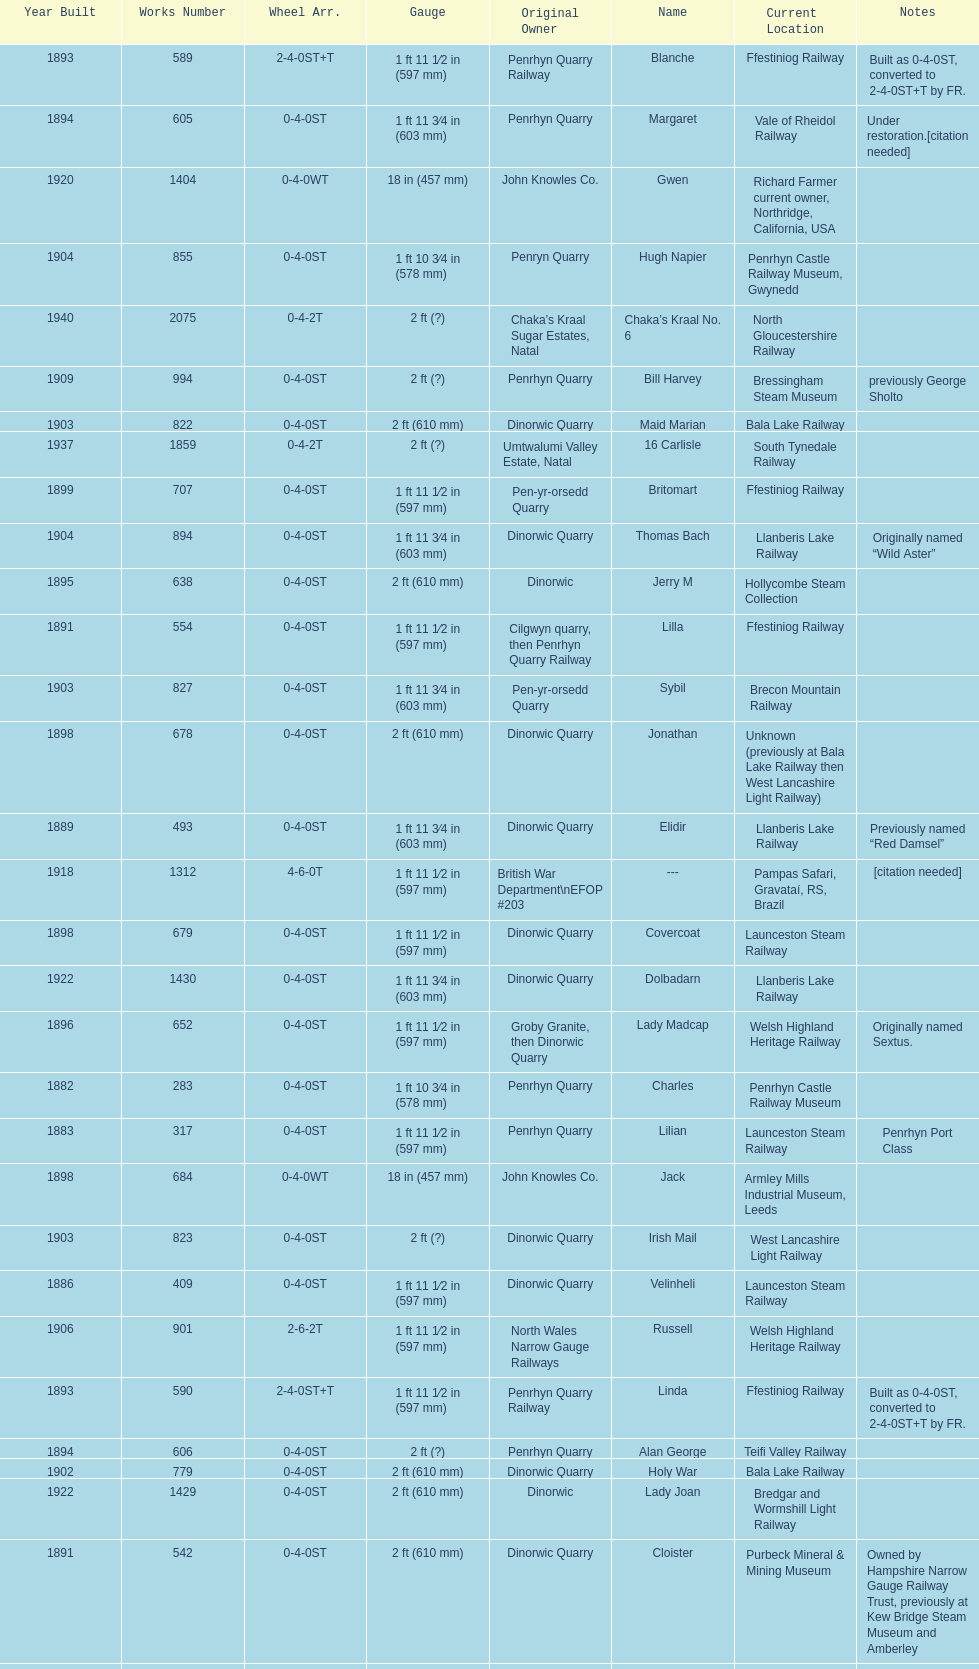What is the name of the last locomotive to be located at the bressingham steam museum? Gwynedd. 